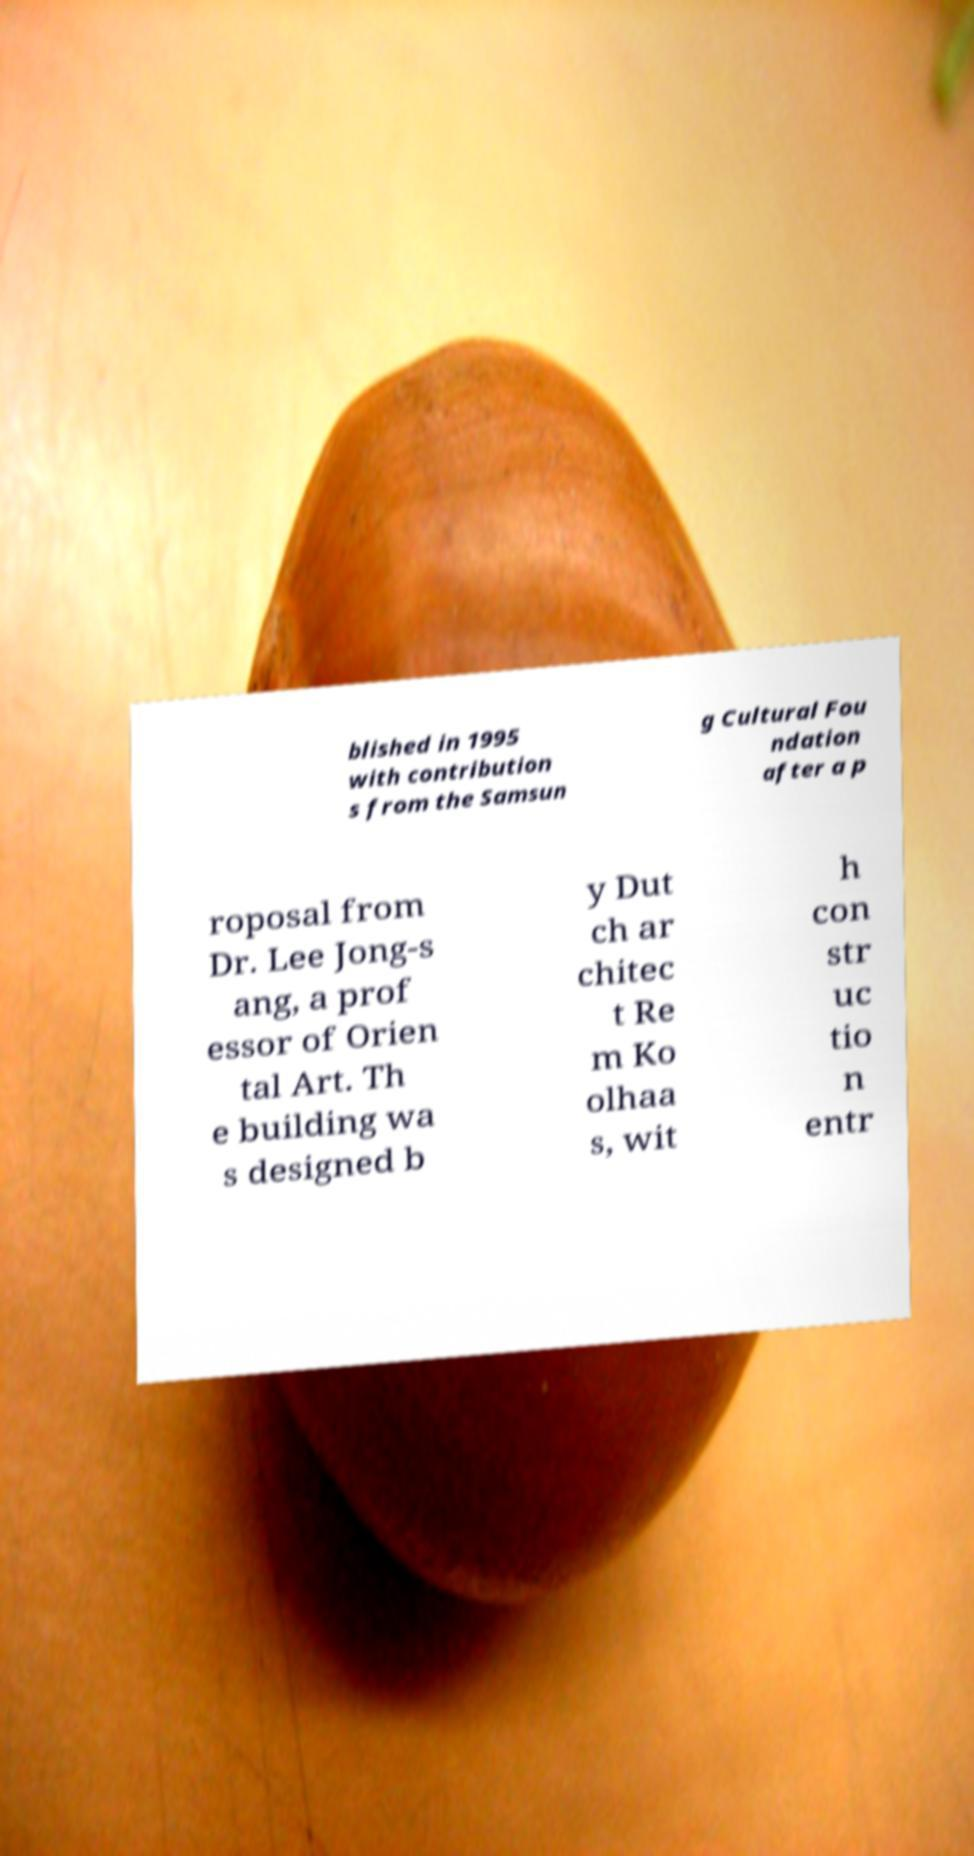There's text embedded in this image that I need extracted. Can you transcribe it verbatim? blished in 1995 with contribution s from the Samsun g Cultural Fou ndation after a p roposal from Dr. Lee Jong-s ang, a prof essor of Orien tal Art. Th e building wa s designed b y Dut ch ar chitec t Re m Ko olhaa s, wit h con str uc tio n entr 